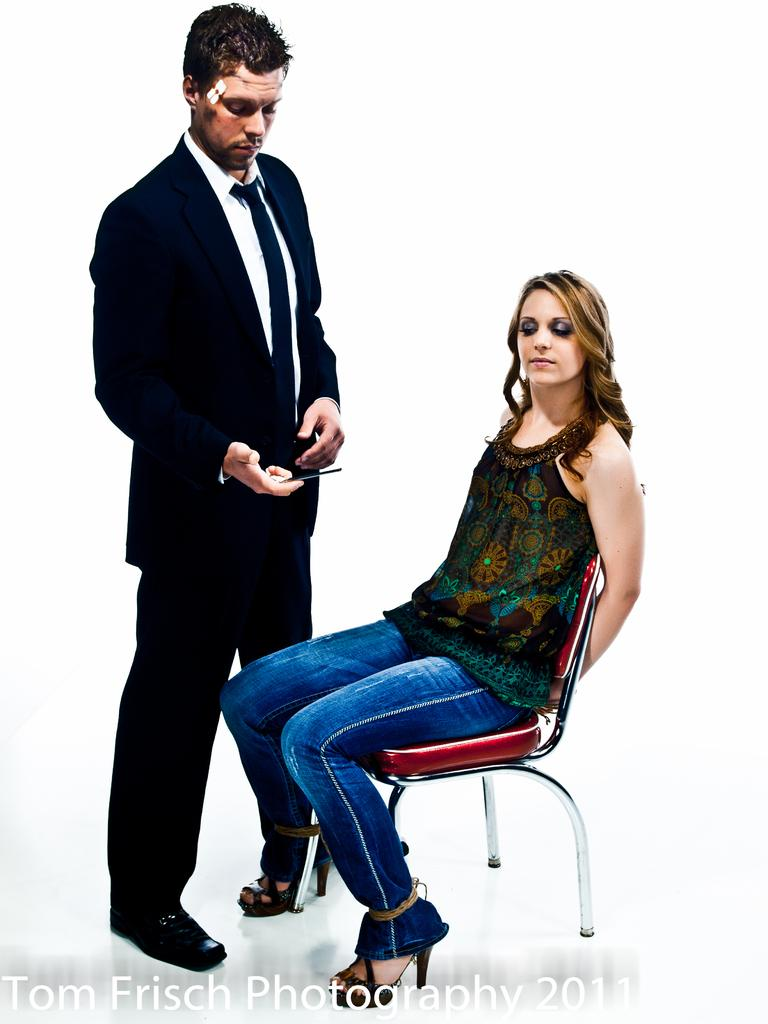What is the appearance of the man in the image? The man in the image is wearing a suit. What is the man doing in the image? The man is standing in the image. Who else is present in the image? There is a woman in the image. What is the woman doing in the image? The woman is sitting on a chair in the image. What are the man and the woman looking at in the image? Both the man and the woman are looking downwards in the image. What type of sack can be seen being twisted by the cattle in the image? There is no sack or cattle present in the image. 